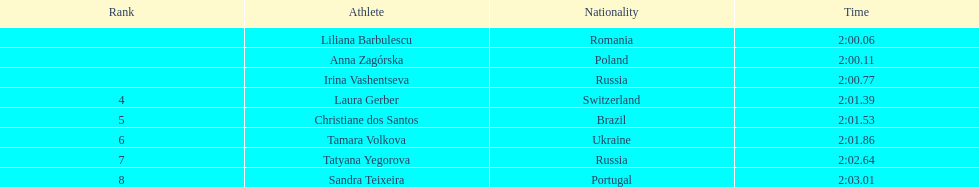Anna zagorska obtained the runner-up spot, what was her time? 2:00.11. 